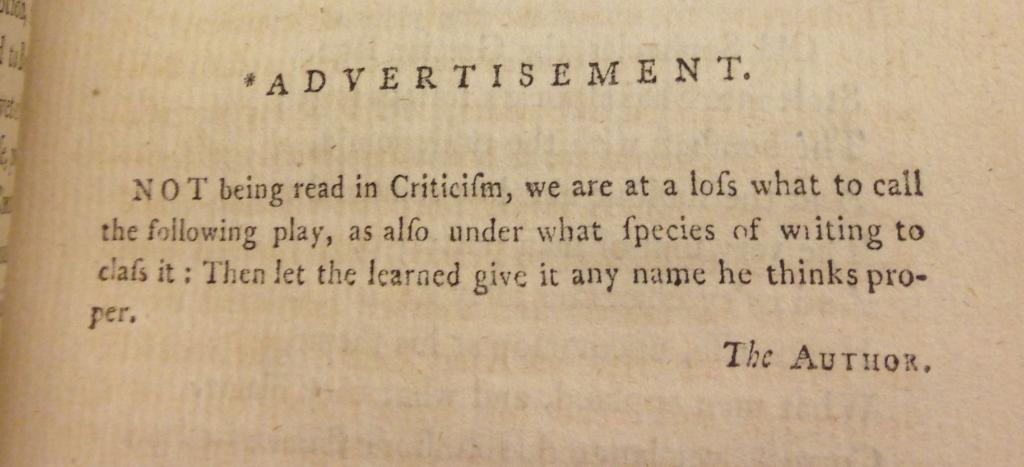What is written at the top of the page?
Give a very brief answer. Advertisement. What is written at the bottom of the page?
Provide a succinct answer. The author. 